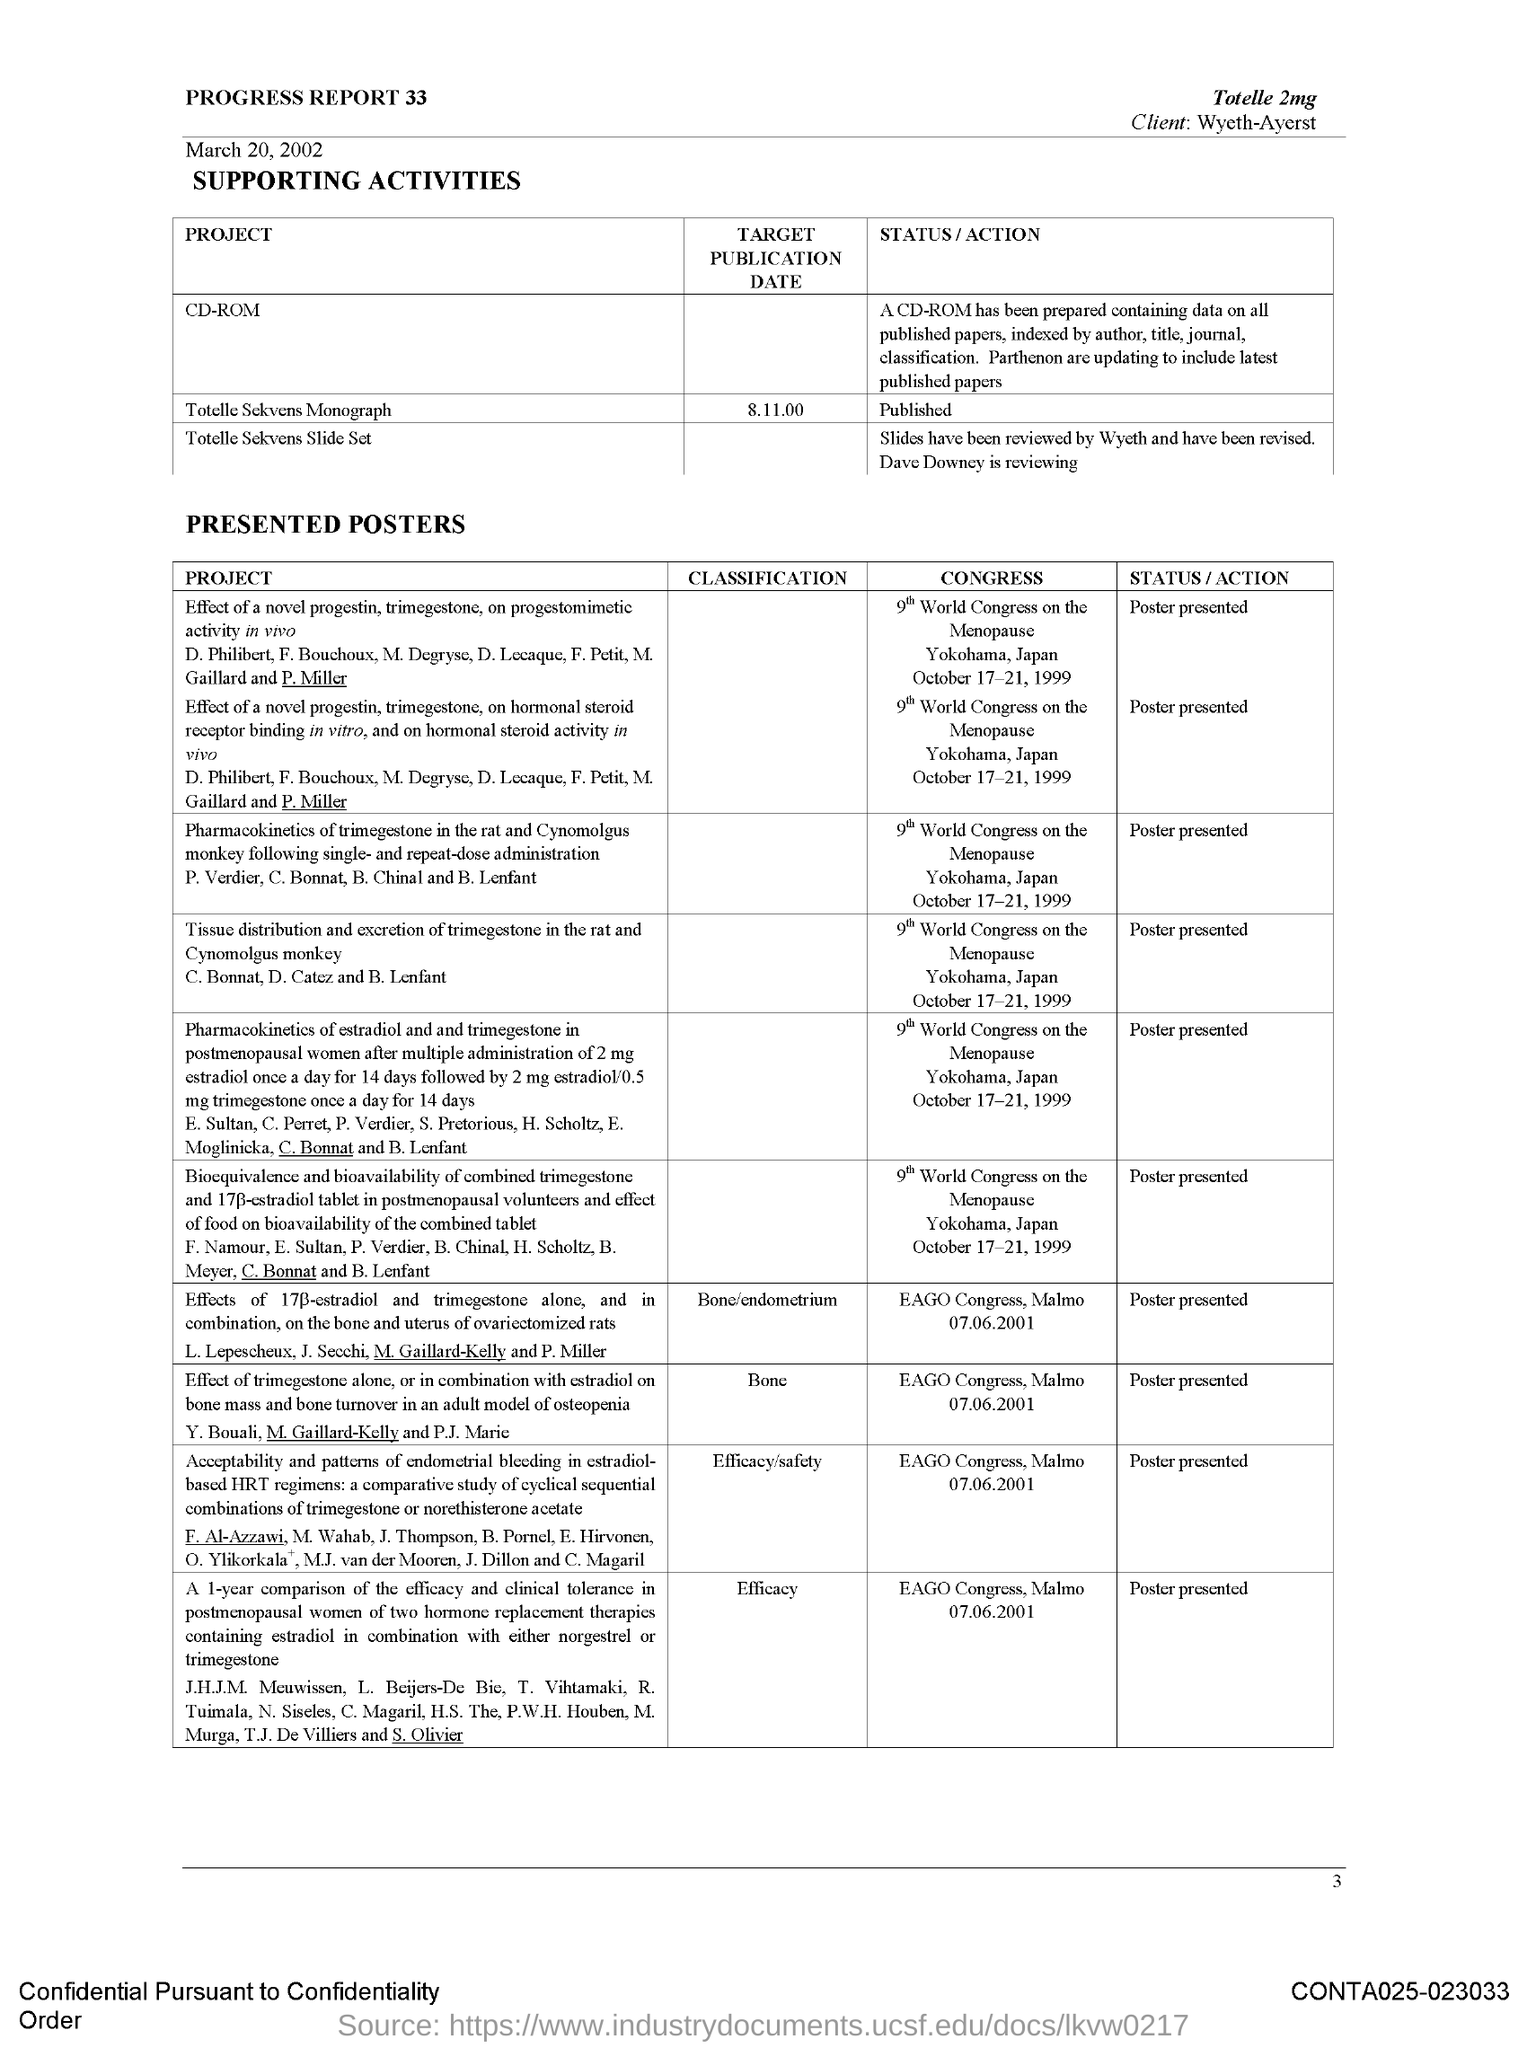Outline some significant characteristics in this image. The client is Wyeth. The Totelle Sekvens Monograph has been published. The medication mentioned is 2mg of "Which medicine is mentioned at the top?". 